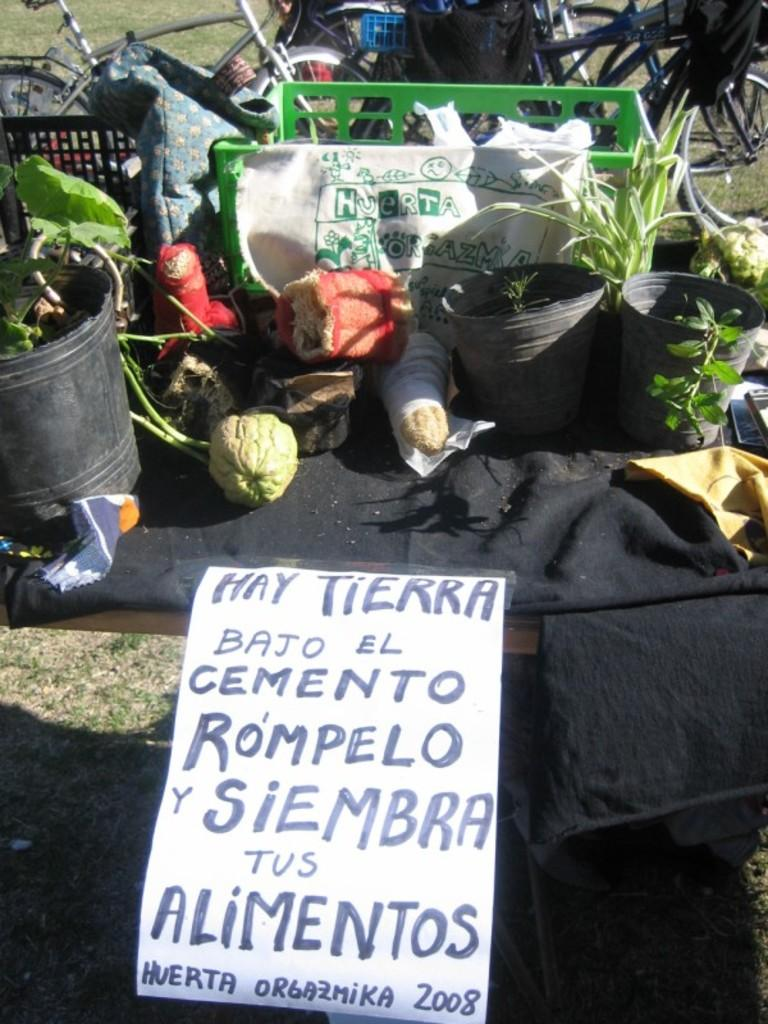What type of objects can be seen in the image? There are pots, vegetables, carry bags, a plastic container, and bicycles present in the image. What can be used to store or transport items in the image? Carry bags and a plastic container can be used to store or transport items in the image. What is the color of the cloth in the image? The cloth in the image is black. What is on the grassy land in the image? There is a poster on the grassy land in the image. Can you see a flock of birds flying over the bicycles in the image? There are no birds or flocks visible in the image; it only features pots, vegetables, carry bags, a plastic container, bicycles, a black color cloth, and a poster on the grassy land. 